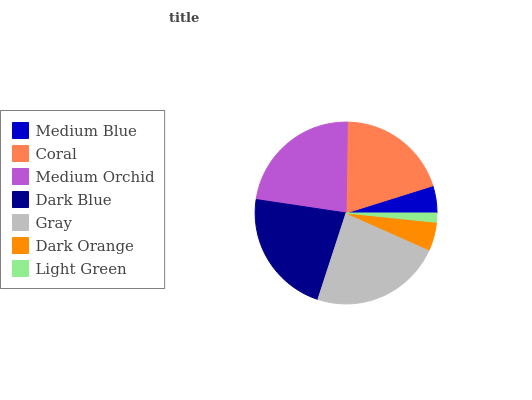Is Light Green the minimum?
Answer yes or no. Yes. Is Gray the maximum?
Answer yes or no. Yes. Is Coral the minimum?
Answer yes or no. No. Is Coral the maximum?
Answer yes or no. No. Is Coral greater than Medium Blue?
Answer yes or no. Yes. Is Medium Blue less than Coral?
Answer yes or no. Yes. Is Medium Blue greater than Coral?
Answer yes or no. No. Is Coral less than Medium Blue?
Answer yes or no. No. Is Coral the high median?
Answer yes or no. Yes. Is Coral the low median?
Answer yes or no. Yes. Is Light Green the high median?
Answer yes or no. No. Is Gray the low median?
Answer yes or no. No. 